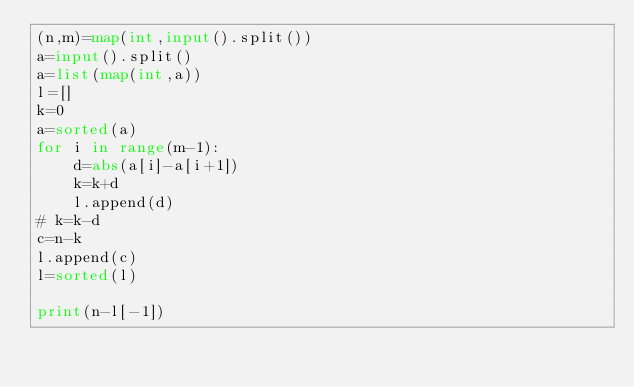<code> <loc_0><loc_0><loc_500><loc_500><_Python_>(n,m)=map(int,input().split())
a=input().split()
a=list(map(int,a))
l=[]
k=0
a=sorted(a)
for i in range(m-1):
    d=abs(a[i]-a[i+1])
    k=k+d
    l.append(d)
# k=k-d
c=n-k
l.append(c)
l=sorted(l)

print(n-l[-1])</code> 